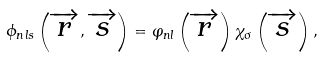<formula> <loc_0><loc_0><loc_500><loc_500>\phi _ { n l s } \left ( \overrightarrow { r } , \overrightarrow { s } \right ) = \varphi _ { n l } \left ( \overrightarrow { r } \right ) \chi _ { \sigma } \left ( \overrightarrow { s } \right ) ,</formula> 